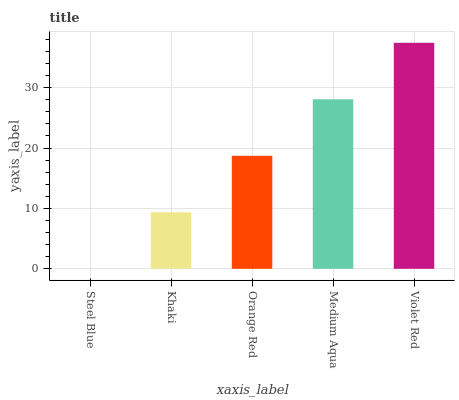Is Khaki the minimum?
Answer yes or no. No. Is Khaki the maximum?
Answer yes or no. No. Is Khaki greater than Steel Blue?
Answer yes or no. Yes. Is Steel Blue less than Khaki?
Answer yes or no. Yes. Is Steel Blue greater than Khaki?
Answer yes or no. No. Is Khaki less than Steel Blue?
Answer yes or no. No. Is Orange Red the high median?
Answer yes or no. Yes. Is Orange Red the low median?
Answer yes or no. Yes. Is Violet Red the high median?
Answer yes or no. No. Is Steel Blue the low median?
Answer yes or no. No. 